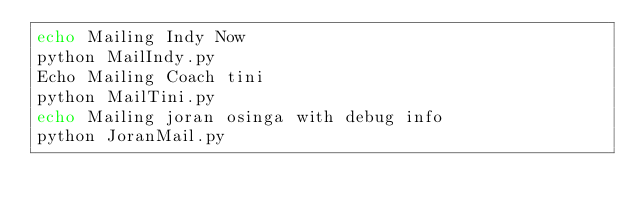<code> <loc_0><loc_0><loc_500><loc_500><_Bash_>echo Mailing Indy Now
python MailIndy.py
Echo Mailing Coach tini
python MailTini.py
echo Mailing joran osinga with debug info
python JoranMail.py
</code> 